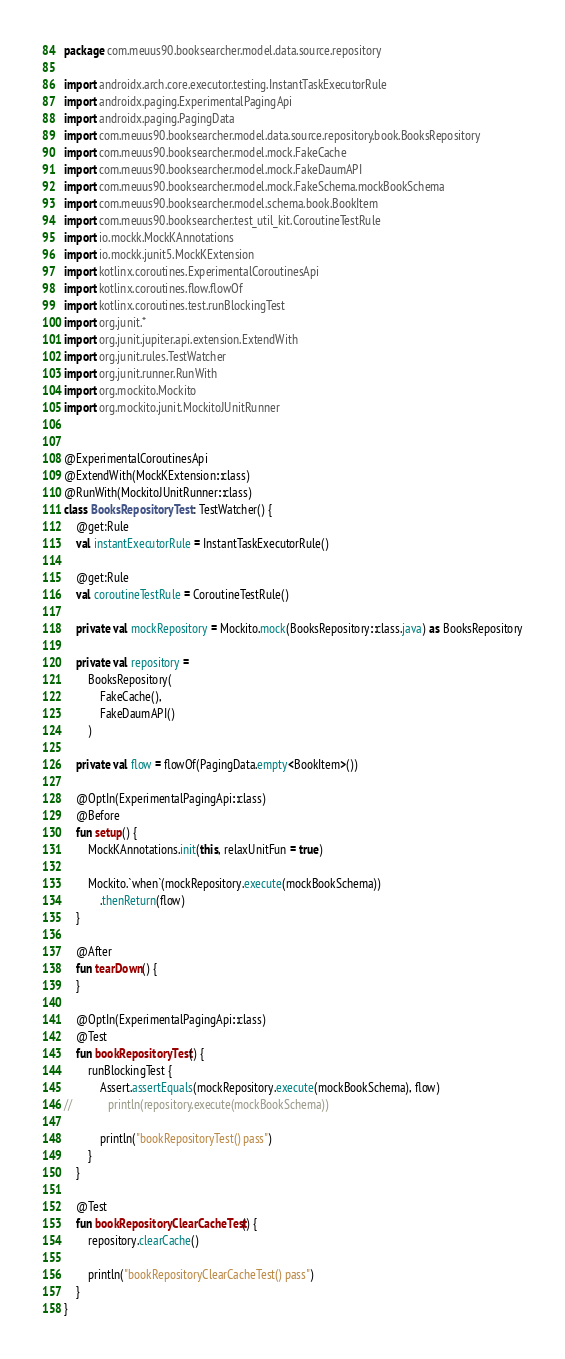<code> <loc_0><loc_0><loc_500><loc_500><_Kotlin_>package com.meuus90.booksearcher.model.data.source.repository

import androidx.arch.core.executor.testing.InstantTaskExecutorRule
import androidx.paging.ExperimentalPagingApi
import androidx.paging.PagingData
import com.meuus90.booksearcher.model.data.source.repository.book.BooksRepository
import com.meuus90.booksearcher.model.mock.FakeCache
import com.meuus90.booksearcher.model.mock.FakeDaumAPI
import com.meuus90.booksearcher.model.mock.FakeSchema.mockBookSchema
import com.meuus90.booksearcher.model.schema.book.BookItem
import com.meuus90.booksearcher.test_util_kit.CoroutineTestRule
import io.mockk.MockKAnnotations
import io.mockk.junit5.MockKExtension
import kotlinx.coroutines.ExperimentalCoroutinesApi
import kotlinx.coroutines.flow.flowOf
import kotlinx.coroutines.test.runBlockingTest
import org.junit.*
import org.junit.jupiter.api.extension.ExtendWith
import org.junit.rules.TestWatcher
import org.junit.runner.RunWith
import org.mockito.Mockito
import org.mockito.junit.MockitoJUnitRunner


@ExperimentalCoroutinesApi
@ExtendWith(MockKExtension::class)
@RunWith(MockitoJUnitRunner::class)
class BooksRepositoryTest : TestWatcher() {
    @get:Rule
    val instantExecutorRule = InstantTaskExecutorRule()

    @get:Rule
    val coroutineTestRule = CoroutineTestRule()

    private val mockRepository = Mockito.mock(BooksRepository::class.java) as BooksRepository

    private val repository =
        BooksRepository(
            FakeCache(),
            FakeDaumAPI()
        )

    private val flow = flowOf(PagingData.empty<BookItem>())

    @OptIn(ExperimentalPagingApi::class)
    @Before
    fun setup() {
        MockKAnnotations.init(this, relaxUnitFun = true)

        Mockito.`when`(mockRepository.execute(mockBookSchema))
            .thenReturn(flow)
    }

    @After
    fun tearDown() {
    }

    @OptIn(ExperimentalPagingApi::class)
    @Test
    fun bookRepositoryTest() {
        runBlockingTest {
            Assert.assertEquals(mockRepository.execute(mockBookSchema), flow)
//            println(repository.execute(mockBookSchema))

            println("bookRepositoryTest() pass")
        }
    }

    @Test
    fun bookRepositoryClearCacheTest() {
        repository.clearCache()

        println("bookRepositoryClearCacheTest() pass")
    }
}</code> 